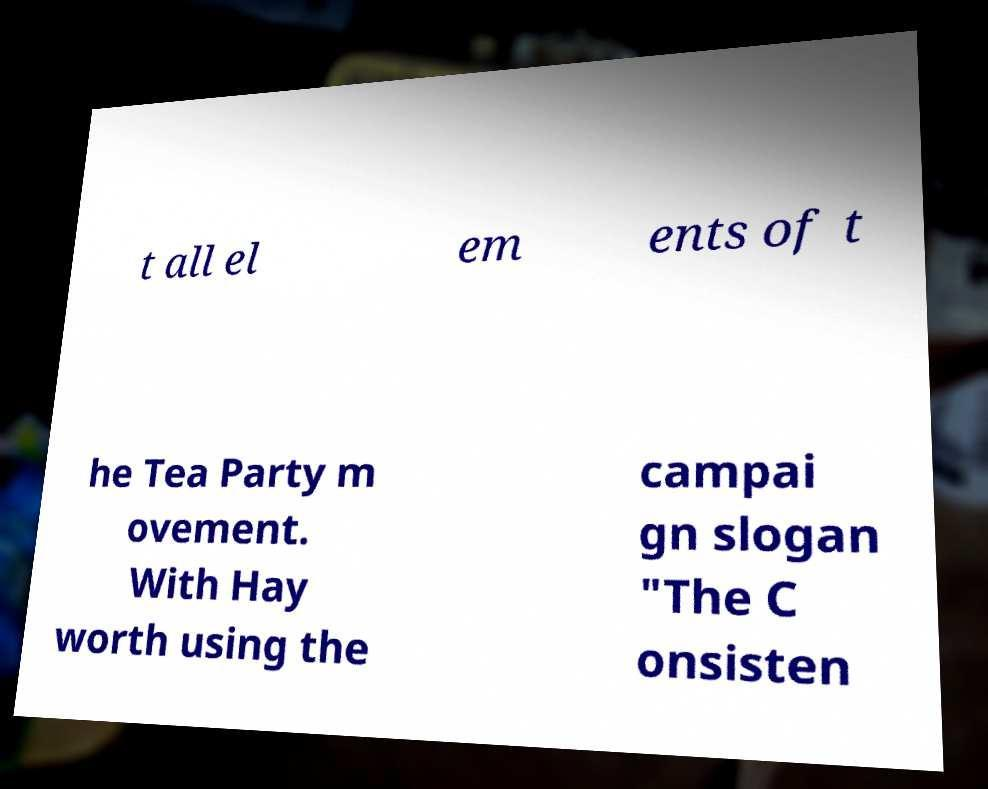Could you assist in decoding the text presented in this image and type it out clearly? t all el em ents of t he Tea Party m ovement. With Hay worth using the campai gn slogan "The C onsisten 